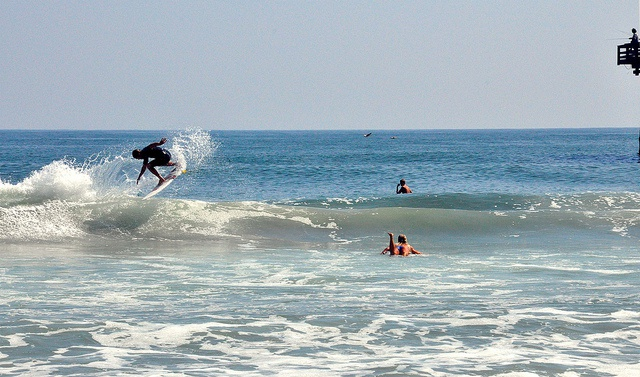Describe the objects in this image and their specific colors. I can see people in darkgray, black, and gray tones, people in darkgray, black, salmon, and maroon tones, surfboard in darkgray, ivory, and gray tones, people in darkgray, black, salmon, and brown tones, and people in darkgray, black, gray, and navy tones in this image. 